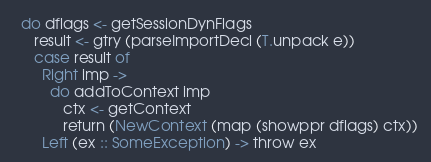<code> <loc_0><loc_0><loc_500><loc_500><_Haskell_>  do dflags <- getSessionDynFlags
     result <- gtry (parseImportDecl (T.unpack e))
     case result of
       Right imp ->
         do addToContext imp
            ctx <- getContext
            return (NewContext (map (showppr dflags) ctx))
       Left (ex :: SomeException) -> throw ex
</code> 